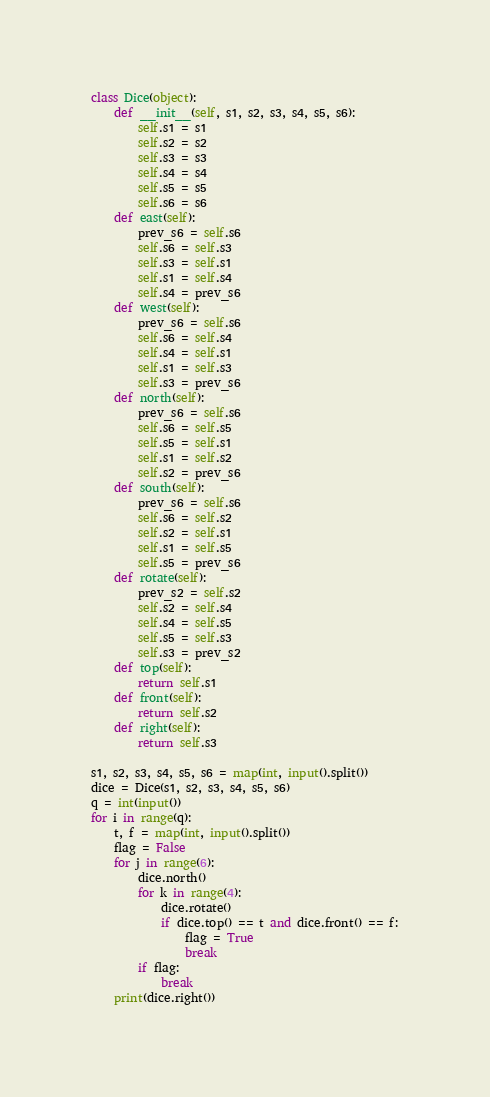<code> <loc_0><loc_0><loc_500><loc_500><_Python_>class Dice(object):
    def __init__(self, s1, s2, s3, s4, s5, s6):
        self.s1 = s1
        self.s2 = s2
        self.s3 = s3
        self.s4 = s4
        self.s5 = s5
        self.s6 = s6
    def east(self):
        prev_s6 = self.s6
        self.s6 = self.s3
        self.s3 = self.s1
        self.s1 = self.s4
        self.s4 = prev_s6
    def west(self):
        prev_s6 = self.s6
        self.s6 = self.s4
        self.s4 = self.s1
        self.s1 = self.s3
        self.s3 = prev_s6
    def north(self):
        prev_s6 = self.s6
        self.s6 = self.s5
        self.s5 = self.s1
        self.s1 = self.s2
        self.s2 = prev_s6
    def south(self):
        prev_s6 = self.s6
        self.s6 = self.s2
        self.s2 = self.s1
        self.s1 = self.s5
        self.s5 = prev_s6
    def rotate(self):
        prev_s2 = self.s2
        self.s2 = self.s4
        self.s4 = self.s5
        self.s5 = self.s3
        self.s3 = prev_s2
    def top(self):
        return self.s1
    def front(self):
        return self.s2
    def right(self):
        return self.s3

s1, s2, s3, s4, s5, s6 = map(int, input().split())
dice = Dice(s1, s2, s3, s4, s5, s6)
q = int(input())
for i in range(q):
    t, f = map(int, input().split())
    flag = False
    for j in range(6):
        dice.north()
        for k in range(4):
            dice.rotate()
            if dice.top() == t and dice.front() == f:
                flag = True
                break
        if flag:
            break
    print(dice.right())</code> 